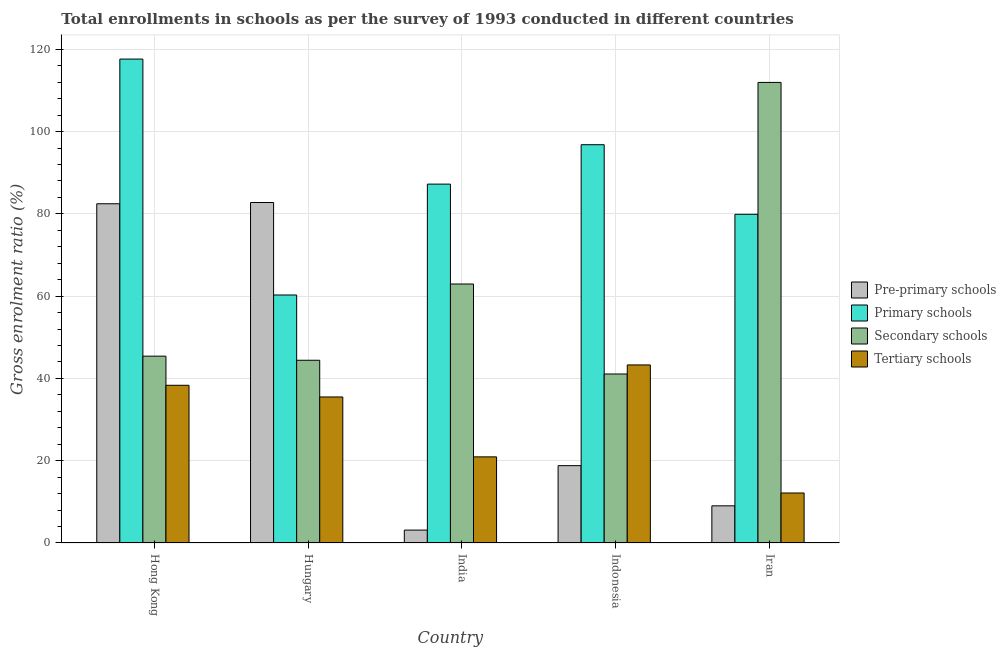How many different coloured bars are there?
Offer a terse response. 4. How many groups of bars are there?
Your answer should be compact. 5. Are the number of bars per tick equal to the number of legend labels?
Your answer should be compact. Yes. What is the label of the 1st group of bars from the left?
Provide a short and direct response. Hong Kong. What is the gross enrolment ratio in primary schools in Iran?
Make the answer very short. 79.9. Across all countries, what is the maximum gross enrolment ratio in pre-primary schools?
Offer a very short reply. 82.77. Across all countries, what is the minimum gross enrolment ratio in primary schools?
Provide a succinct answer. 60.28. In which country was the gross enrolment ratio in secondary schools maximum?
Your answer should be very brief. Iran. What is the total gross enrolment ratio in pre-primary schools in the graph?
Your answer should be compact. 196.2. What is the difference between the gross enrolment ratio in tertiary schools in India and that in Iran?
Give a very brief answer. 8.78. What is the difference between the gross enrolment ratio in tertiary schools in Indonesia and the gross enrolment ratio in primary schools in India?
Give a very brief answer. -43.95. What is the average gross enrolment ratio in pre-primary schools per country?
Offer a terse response. 39.24. What is the difference between the gross enrolment ratio in primary schools and gross enrolment ratio in tertiary schools in Hungary?
Your answer should be compact. 24.79. In how many countries, is the gross enrolment ratio in primary schools greater than 32 %?
Make the answer very short. 5. What is the ratio of the gross enrolment ratio in primary schools in Hungary to that in Iran?
Provide a succinct answer. 0.75. Is the gross enrolment ratio in secondary schools in Hungary less than that in Indonesia?
Your answer should be compact. No. Is the difference between the gross enrolment ratio in pre-primary schools in Hong Kong and Iran greater than the difference between the gross enrolment ratio in secondary schools in Hong Kong and Iran?
Your answer should be very brief. Yes. What is the difference between the highest and the second highest gross enrolment ratio in tertiary schools?
Your response must be concise. 4.95. What is the difference between the highest and the lowest gross enrolment ratio in primary schools?
Give a very brief answer. 57.35. In how many countries, is the gross enrolment ratio in secondary schools greater than the average gross enrolment ratio in secondary schools taken over all countries?
Offer a terse response. 2. Is it the case that in every country, the sum of the gross enrolment ratio in secondary schools and gross enrolment ratio in pre-primary schools is greater than the sum of gross enrolment ratio in tertiary schools and gross enrolment ratio in primary schools?
Ensure brevity in your answer.  No. What does the 4th bar from the left in Hungary represents?
Make the answer very short. Tertiary schools. What does the 4th bar from the right in Hong Kong represents?
Give a very brief answer. Pre-primary schools. Is it the case that in every country, the sum of the gross enrolment ratio in pre-primary schools and gross enrolment ratio in primary schools is greater than the gross enrolment ratio in secondary schools?
Offer a terse response. No. How many bars are there?
Your answer should be very brief. 20. Are all the bars in the graph horizontal?
Provide a succinct answer. No. How many countries are there in the graph?
Provide a short and direct response. 5. Are the values on the major ticks of Y-axis written in scientific E-notation?
Make the answer very short. No. Does the graph contain any zero values?
Offer a terse response. No. What is the title of the graph?
Offer a terse response. Total enrollments in schools as per the survey of 1993 conducted in different countries. Does "Regional development banks" appear as one of the legend labels in the graph?
Provide a short and direct response. No. What is the label or title of the X-axis?
Your response must be concise. Country. What is the label or title of the Y-axis?
Provide a short and direct response. Gross enrolment ratio (%). What is the Gross enrolment ratio (%) in Pre-primary schools in Hong Kong?
Offer a terse response. 82.46. What is the Gross enrolment ratio (%) of Primary schools in Hong Kong?
Your response must be concise. 117.63. What is the Gross enrolment ratio (%) of Secondary schools in Hong Kong?
Your response must be concise. 45.42. What is the Gross enrolment ratio (%) in Tertiary schools in Hong Kong?
Your response must be concise. 38.33. What is the Gross enrolment ratio (%) of Pre-primary schools in Hungary?
Keep it short and to the point. 82.77. What is the Gross enrolment ratio (%) of Primary schools in Hungary?
Offer a terse response. 60.28. What is the Gross enrolment ratio (%) in Secondary schools in Hungary?
Provide a succinct answer. 44.42. What is the Gross enrolment ratio (%) of Tertiary schools in Hungary?
Your answer should be compact. 35.5. What is the Gross enrolment ratio (%) of Pre-primary schools in India?
Your response must be concise. 3.14. What is the Gross enrolment ratio (%) of Primary schools in India?
Keep it short and to the point. 87.24. What is the Gross enrolment ratio (%) of Secondary schools in India?
Your response must be concise. 62.95. What is the Gross enrolment ratio (%) in Tertiary schools in India?
Give a very brief answer. 20.93. What is the Gross enrolment ratio (%) in Pre-primary schools in Indonesia?
Your answer should be very brief. 18.8. What is the Gross enrolment ratio (%) in Primary schools in Indonesia?
Keep it short and to the point. 96.82. What is the Gross enrolment ratio (%) in Secondary schools in Indonesia?
Make the answer very short. 41.08. What is the Gross enrolment ratio (%) of Tertiary schools in Indonesia?
Give a very brief answer. 43.28. What is the Gross enrolment ratio (%) in Pre-primary schools in Iran?
Give a very brief answer. 9.03. What is the Gross enrolment ratio (%) in Primary schools in Iran?
Offer a very short reply. 79.9. What is the Gross enrolment ratio (%) in Secondary schools in Iran?
Your answer should be compact. 111.96. What is the Gross enrolment ratio (%) in Tertiary schools in Iran?
Keep it short and to the point. 12.15. Across all countries, what is the maximum Gross enrolment ratio (%) in Pre-primary schools?
Offer a very short reply. 82.77. Across all countries, what is the maximum Gross enrolment ratio (%) in Primary schools?
Your answer should be compact. 117.63. Across all countries, what is the maximum Gross enrolment ratio (%) of Secondary schools?
Provide a short and direct response. 111.96. Across all countries, what is the maximum Gross enrolment ratio (%) in Tertiary schools?
Offer a very short reply. 43.28. Across all countries, what is the minimum Gross enrolment ratio (%) of Pre-primary schools?
Your answer should be very brief. 3.14. Across all countries, what is the minimum Gross enrolment ratio (%) of Primary schools?
Make the answer very short. 60.28. Across all countries, what is the minimum Gross enrolment ratio (%) in Secondary schools?
Offer a terse response. 41.08. Across all countries, what is the minimum Gross enrolment ratio (%) of Tertiary schools?
Keep it short and to the point. 12.15. What is the total Gross enrolment ratio (%) of Pre-primary schools in the graph?
Your response must be concise. 196.2. What is the total Gross enrolment ratio (%) in Primary schools in the graph?
Provide a succinct answer. 441.87. What is the total Gross enrolment ratio (%) of Secondary schools in the graph?
Offer a very short reply. 305.83. What is the total Gross enrolment ratio (%) of Tertiary schools in the graph?
Provide a short and direct response. 150.2. What is the difference between the Gross enrolment ratio (%) of Pre-primary schools in Hong Kong and that in Hungary?
Provide a short and direct response. -0.31. What is the difference between the Gross enrolment ratio (%) in Primary schools in Hong Kong and that in Hungary?
Your answer should be compact. 57.35. What is the difference between the Gross enrolment ratio (%) of Secondary schools in Hong Kong and that in Hungary?
Offer a very short reply. 1. What is the difference between the Gross enrolment ratio (%) of Tertiary schools in Hong Kong and that in Hungary?
Make the answer very short. 2.84. What is the difference between the Gross enrolment ratio (%) of Pre-primary schools in Hong Kong and that in India?
Offer a very short reply. 79.33. What is the difference between the Gross enrolment ratio (%) of Primary schools in Hong Kong and that in India?
Offer a very short reply. 30.4. What is the difference between the Gross enrolment ratio (%) in Secondary schools in Hong Kong and that in India?
Keep it short and to the point. -17.54. What is the difference between the Gross enrolment ratio (%) in Tertiary schools in Hong Kong and that in India?
Your answer should be compact. 17.4. What is the difference between the Gross enrolment ratio (%) in Pre-primary schools in Hong Kong and that in Indonesia?
Provide a short and direct response. 63.66. What is the difference between the Gross enrolment ratio (%) of Primary schools in Hong Kong and that in Indonesia?
Provide a short and direct response. 20.82. What is the difference between the Gross enrolment ratio (%) of Secondary schools in Hong Kong and that in Indonesia?
Your response must be concise. 4.34. What is the difference between the Gross enrolment ratio (%) in Tertiary schools in Hong Kong and that in Indonesia?
Your response must be concise. -4.95. What is the difference between the Gross enrolment ratio (%) in Pre-primary schools in Hong Kong and that in Iran?
Provide a short and direct response. 73.43. What is the difference between the Gross enrolment ratio (%) of Primary schools in Hong Kong and that in Iran?
Your response must be concise. 37.73. What is the difference between the Gross enrolment ratio (%) in Secondary schools in Hong Kong and that in Iran?
Provide a short and direct response. -66.54. What is the difference between the Gross enrolment ratio (%) of Tertiary schools in Hong Kong and that in Iran?
Keep it short and to the point. 26.18. What is the difference between the Gross enrolment ratio (%) of Pre-primary schools in Hungary and that in India?
Your answer should be compact. 79.63. What is the difference between the Gross enrolment ratio (%) of Primary schools in Hungary and that in India?
Keep it short and to the point. -26.95. What is the difference between the Gross enrolment ratio (%) of Secondary schools in Hungary and that in India?
Ensure brevity in your answer.  -18.54. What is the difference between the Gross enrolment ratio (%) of Tertiary schools in Hungary and that in India?
Your response must be concise. 14.56. What is the difference between the Gross enrolment ratio (%) in Pre-primary schools in Hungary and that in Indonesia?
Ensure brevity in your answer.  63.97. What is the difference between the Gross enrolment ratio (%) of Primary schools in Hungary and that in Indonesia?
Your answer should be very brief. -36.53. What is the difference between the Gross enrolment ratio (%) of Secondary schools in Hungary and that in Indonesia?
Keep it short and to the point. 3.34. What is the difference between the Gross enrolment ratio (%) of Tertiary schools in Hungary and that in Indonesia?
Make the answer very short. -7.79. What is the difference between the Gross enrolment ratio (%) in Pre-primary schools in Hungary and that in Iran?
Provide a succinct answer. 73.74. What is the difference between the Gross enrolment ratio (%) of Primary schools in Hungary and that in Iran?
Ensure brevity in your answer.  -19.62. What is the difference between the Gross enrolment ratio (%) in Secondary schools in Hungary and that in Iran?
Make the answer very short. -67.54. What is the difference between the Gross enrolment ratio (%) of Tertiary schools in Hungary and that in Iran?
Provide a succinct answer. 23.34. What is the difference between the Gross enrolment ratio (%) of Pre-primary schools in India and that in Indonesia?
Provide a short and direct response. -15.66. What is the difference between the Gross enrolment ratio (%) of Primary schools in India and that in Indonesia?
Make the answer very short. -9.58. What is the difference between the Gross enrolment ratio (%) of Secondary schools in India and that in Indonesia?
Your response must be concise. 21.87. What is the difference between the Gross enrolment ratio (%) in Tertiary schools in India and that in Indonesia?
Provide a short and direct response. -22.35. What is the difference between the Gross enrolment ratio (%) of Pre-primary schools in India and that in Iran?
Your answer should be compact. -5.9. What is the difference between the Gross enrolment ratio (%) in Primary schools in India and that in Iran?
Provide a short and direct response. 7.33. What is the difference between the Gross enrolment ratio (%) in Secondary schools in India and that in Iran?
Keep it short and to the point. -49. What is the difference between the Gross enrolment ratio (%) in Tertiary schools in India and that in Iran?
Provide a short and direct response. 8.78. What is the difference between the Gross enrolment ratio (%) in Pre-primary schools in Indonesia and that in Iran?
Provide a succinct answer. 9.77. What is the difference between the Gross enrolment ratio (%) in Primary schools in Indonesia and that in Iran?
Provide a succinct answer. 16.92. What is the difference between the Gross enrolment ratio (%) in Secondary schools in Indonesia and that in Iran?
Keep it short and to the point. -70.88. What is the difference between the Gross enrolment ratio (%) in Tertiary schools in Indonesia and that in Iran?
Your answer should be compact. 31.13. What is the difference between the Gross enrolment ratio (%) of Pre-primary schools in Hong Kong and the Gross enrolment ratio (%) of Primary schools in Hungary?
Offer a very short reply. 22.18. What is the difference between the Gross enrolment ratio (%) of Pre-primary schools in Hong Kong and the Gross enrolment ratio (%) of Secondary schools in Hungary?
Your answer should be very brief. 38.04. What is the difference between the Gross enrolment ratio (%) of Pre-primary schools in Hong Kong and the Gross enrolment ratio (%) of Tertiary schools in Hungary?
Give a very brief answer. 46.97. What is the difference between the Gross enrolment ratio (%) of Primary schools in Hong Kong and the Gross enrolment ratio (%) of Secondary schools in Hungary?
Ensure brevity in your answer.  73.21. What is the difference between the Gross enrolment ratio (%) in Primary schools in Hong Kong and the Gross enrolment ratio (%) in Tertiary schools in Hungary?
Offer a terse response. 82.14. What is the difference between the Gross enrolment ratio (%) of Secondary schools in Hong Kong and the Gross enrolment ratio (%) of Tertiary schools in Hungary?
Give a very brief answer. 9.92. What is the difference between the Gross enrolment ratio (%) in Pre-primary schools in Hong Kong and the Gross enrolment ratio (%) in Primary schools in India?
Give a very brief answer. -4.77. What is the difference between the Gross enrolment ratio (%) in Pre-primary schools in Hong Kong and the Gross enrolment ratio (%) in Secondary schools in India?
Offer a terse response. 19.51. What is the difference between the Gross enrolment ratio (%) in Pre-primary schools in Hong Kong and the Gross enrolment ratio (%) in Tertiary schools in India?
Provide a short and direct response. 61.53. What is the difference between the Gross enrolment ratio (%) of Primary schools in Hong Kong and the Gross enrolment ratio (%) of Secondary schools in India?
Your answer should be compact. 54.68. What is the difference between the Gross enrolment ratio (%) in Primary schools in Hong Kong and the Gross enrolment ratio (%) in Tertiary schools in India?
Provide a short and direct response. 96.7. What is the difference between the Gross enrolment ratio (%) of Secondary schools in Hong Kong and the Gross enrolment ratio (%) of Tertiary schools in India?
Offer a terse response. 24.48. What is the difference between the Gross enrolment ratio (%) in Pre-primary schools in Hong Kong and the Gross enrolment ratio (%) in Primary schools in Indonesia?
Your answer should be compact. -14.36. What is the difference between the Gross enrolment ratio (%) of Pre-primary schools in Hong Kong and the Gross enrolment ratio (%) of Secondary schools in Indonesia?
Your answer should be compact. 41.38. What is the difference between the Gross enrolment ratio (%) in Pre-primary schools in Hong Kong and the Gross enrolment ratio (%) in Tertiary schools in Indonesia?
Keep it short and to the point. 39.18. What is the difference between the Gross enrolment ratio (%) in Primary schools in Hong Kong and the Gross enrolment ratio (%) in Secondary schools in Indonesia?
Offer a very short reply. 76.55. What is the difference between the Gross enrolment ratio (%) in Primary schools in Hong Kong and the Gross enrolment ratio (%) in Tertiary schools in Indonesia?
Provide a short and direct response. 74.35. What is the difference between the Gross enrolment ratio (%) in Secondary schools in Hong Kong and the Gross enrolment ratio (%) in Tertiary schools in Indonesia?
Offer a very short reply. 2.13. What is the difference between the Gross enrolment ratio (%) of Pre-primary schools in Hong Kong and the Gross enrolment ratio (%) of Primary schools in Iran?
Provide a succinct answer. 2.56. What is the difference between the Gross enrolment ratio (%) in Pre-primary schools in Hong Kong and the Gross enrolment ratio (%) in Secondary schools in Iran?
Keep it short and to the point. -29.5. What is the difference between the Gross enrolment ratio (%) of Pre-primary schools in Hong Kong and the Gross enrolment ratio (%) of Tertiary schools in Iran?
Provide a short and direct response. 70.31. What is the difference between the Gross enrolment ratio (%) in Primary schools in Hong Kong and the Gross enrolment ratio (%) in Secondary schools in Iran?
Offer a terse response. 5.68. What is the difference between the Gross enrolment ratio (%) of Primary schools in Hong Kong and the Gross enrolment ratio (%) of Tertiary schools in Iran?
Make the answer very short. 105.48. What is the difference between the Gross enrolment ratio (%) in Secondary schools in Hong Kong and the Gross enrolment ratio (%) in Tertiary schools in Iran?
Ensure brevity in your answer.  33.27. What is the difference between the Gross enrolment ratio (%) of Pre-primary schools in Hungary and the Gross enrolment ratio (%) of Primary schools in India?
Ensure brevity in your answer.  -4.47. What is the difference between the Gross enrolment ratio (%) of Pre-primary schools in Hungary and the Gross enrolment ratio (%) of Secondary schools in India?
Your answer should be very brief. 19.81. What is the difference between the Gross enrolment ratio (%) of Pre-primary schools in Hungary and the Gross enrolment ratio (%) of Tertiary schools in India?
Provide a short and direct response. 61.83. What is the difference between the Gross enrolment ratio (%) of Primary schools in Hungary and the Gross enrolment ratio (%) of Secondary schools in India?
Give a very brief answer. -2.67. What is the difference between the Gross enrolment ratio (%) in Primary schools in Hungary and the Gross enrolment ratio (%) in Tertiary schools in India?
Provide a short and direct response. 39.35. What is the difference between the Gross enrolment ratio (%) in Secondary schools in Hungary and the Gross enrolment ratio (%) in Tertiary schools in India?
Your answer should be very brief. 23.48. What is the difference between the Gross enrolment ratio (%) of Pre-primary schools in Hungary and the Gross enrolment ratio (%) of Primary schools in Indonesia?
Offer a terse response. -14.05. What is the difference between the Gross enrolment ratio (%) of Pre-primary schools in Hungary and the Gross enrolment ratio (%) of Secondary schools in Indonesia?
Your answer should be compact. 41.69. What is the difference between the Gross enrolment ratio (%) in Pre-primary schools in Hungary and the Gross enrolment ratio (%) in Tertiary schools in Indonesia?
Make the answer very short. 39.48. What is the difference between the Gross enrolment ratio (%) in Primary schools in Hungary and the Gross enrolment ratio (%) in Secondary schools in Indonesia?
Your response must be concise. 19.2. What is the difference between the Gross enrolment ratio (%) in Primary schools in Hungary and the Gross enrolment ratio (%) in Tertiary schools in Indonesia?
Give a very brief answer. 17. What is the difference between the Gross enrolment ratio (%) in Secondary schools in Hungary and the Gross enrolment ratio (%) in Tertiary schools in Indonesia?
Ensure brevity in your answer.  1.13. What is the difference between the Gross enrolment ratio (%) of Pre-primary schools in Hungary and the Gross enrolment ratio (%) of Primary schools in Iran?
Your answer should be compact. 2.87. What is the difference between the Gross enrolment ratio (%) in Pre-primary schools in Hungary and the Gross enrolment ratio (%) in Secondary schools in Iran?
Your answer should be very brief. -29.19. What is the difference between the Gross enrolment ratio (%) in Pre-primary schools in Hungary and the Gross enrolment ratio (%) in Tertiary schools in Iran?
Offer a very short reply. 70.61. What is the difference between the Gross enrolment ratio (%) in Primary schools in Hungary and the Gross enrolment ratio (%) in Secondary schools in Iran?
Your answer should be very brief. -51.67. What is the difference between the Gross enrolment ratio (%) in Primary schools in Hungary and the Gross enrolment ratio (%) in Tertiary schools in Iran?
Offer a very short reply. 48.13. What is the difference between the Gross enrolment ratio (%) in Secondary schools in Hungary and the Gross enrolment ratio (%) in Tertiary schools in Iran?
Your answer should be very brief. 32.27. What is the difference between the Gross enrolment ratio (%) in Pre-primary schools in India and the Gross enrolment ratio (%) in Primary schools in Indonesia?
Offer a very short reply. -93.68. What is the difference between the Gross enrolment ratio (%) in Pre-primary schools in India and the Gross enrolment ratio (%) in Secondary schools in Indonesia?
Your response must be concise. -37.95. What is the difference between the Gross enrolment ratio (%) in Pre-primary schools in India and the Gross enrolment ratio (%) in Tertiary schools in Indonesia?
Your answer should be compact. -40.15. What is the difference between the Gross enrolment ratio (%) in Primary schools in India and the Gross enrolment ratio (%) in Secondary schools in Indonesia?
Offer a terse response. 46.15. What is the difference between the Gross enrolment ratio (%) of Primary schools in India and the Gross enrolment ratio (%) of Tertiary schools in Indonesia?
Offer a very short reply. 43.95. What is the difference between the Gross enrolment ratio (%) of Secondary schools in India and the Gross enrolment ratio (%) of Tertiary schools in Indonesia?
Keep it short and to the point. 19.67. What is the difference between the Gross enrolment ratio (%) of Pre-primary schools in India and the Gross enrolment ratio (%) of Primary schools in Iran?
Offer a very short reply. -76.77. What is the difference between the Gross enrolment ratio (%) of Pre-primary schools in India and the Gross enrolment ratio (%) of Secondary schools in Iran?
Offer a very short reply. -108.82. What is the difference between the Gross enrolment ratio (%) of Pre-primary schools in India and the Gross enrolment ratio (%) of Tertiary schools in Iran?
Give a very brief answer. -9.02. What is the difference between the Gross enrolment ratio (%) of Primary schools in India and the Gross enrolment ratio (%) of Secondary schools in Iran?
Your answer should be compact. -24.72. What is the difference between the Gross enrolment ratio (%) in Primary schools in India and the Gross enrolment ratio (%) in Tertiary schools in Iran?
Provide a succinct answer. 75.08. What is the difference between the Gross enrolment ratio (%) in Secondary schools in India and the Gross enrolment ratio (%) in Tertiary schools in Iran?
Ensure brevity in your answer.  50.8. What is the difference between the Gross enrolment ratio (%) in Pre-primary schools in Indonesia and the Gross enrolment ratio (%) in Primary schools in Iran?
Ensure brevity in your answer.  -61.1. What is the difference between the Gross enrolment ratio (%) of Pre-primary schools in Indonesia and the Gross enrolment ratio (%) of Secondary schools in Iran?
Ensure brevity in your answer.  -93.16. What is the difference between the Gross enrolment ratio (%) in Pre-primary schools in Indonesia and the Gross enrolment ratio (%) in Tertiary schools in Iran?
Provide a short and direct response. 6.65. What is the difference between the Gross enrolment ratio (%) of Primary schools in Indonesia and the Gross enrolment ratio (%) of Secondary schools in Iran?
Your answer should be compact. -15.14. What is the difference between the Gross enrolment ratio (%) in Primary schools in Indonesia and the Gross enrolment ratio (%) in Tertiary schools in Iran?
Give a very brief answer. 84.66. What is the difference between the Gross enrolment ratio (%) of Secondary schools in Indonesia and the Gross enrolment ratio (%) of Tertiary schools in Iran?
Keep it short and to the point. 28.93. What is the average Gross enrolment ratio (%) in Pre-primary schools per country?
Offer a terse response. 39.24. What is the average Gross enrolment ratio (%) in Primary schools per country?
Your answer should be compact. 88.37. What is the average Gross enrolment ratio (%) in Secondary schools per country?
Your response must be concise. 61.17. What is the average Gross enrolment ratio (%) in Tertiary schools per country?
Your answer should be very brief. 30.04. What is the difference between the Gross enrolment ratio (%) of Pre-primary schools and Gross enrolment ratio (%) of Primary schools in Hong Kong?
Provide a short and direct response. -35.17. What is the difference between the Gross enrolment ratio (%) of Pre-primary schools and Gross enrolment ratio (%) of Secondary schools in Hong Kong?
Offer a very short reply. 37.04. What is the difference between the Gross enrolment ratio (%) of Pre-primary schools and Gross enrolment ratio (%) of Tertiary schools in Hong Kong?
Offer a terse response. 44.13. What is the difference between the Gross enrolment ratio (%) of Primary schools and Gross enrolment ratio (%) of Secondary schools in Hong Kong?
Offer a terse response. 72.22. What is the difference between the Gross enrolment ratio (%) in Primary schools and Gross enrolment ratio (%) in Tertiary schools in Hong Kong?
Give a very brief answer. 79.3. What is the difference between the Gross enrolment ratio (%) in Secondary schools and Gross enrolment ratio (%) in Tertiary schools in Hong Kong?
Your answer should be very brief. 7.08. What is the difference between the Gross enrolment ratio (%) in Pre-primary schools and Gross enrolment ratio (%) in Primary schools in Hungary?
Give a very brief answer. 22.48. What is the difference between the Gross enrolment ratio (%) of Pre-primary schools and Gross enrolment ratio (%) of Secondary schools in Hungary?
Offer a terse response. 38.35. What is the difference between the Gross enrolment ratio (%) of Pre-primary schools and Gross enrolment ratio (%) of Tertiary schools in Hungary?
Provide a succinct answer. 47.27. What is the difference between the Gross enrolment ratio (%) in Primary schools and Gross enrolment ratio (%) in Secondary schools in Hungary?
Your answer should be compact. 15.87. What is the difference between the Gross enrolment ratio (%) of Primary schools and Gross enrolment ratio (%) of Tertiary schools in Hungary?
Make the answer very short. 24.79. What is the difference between the Gross enrolment ratio (%) of Secondary schools and Gross enrolment ratio (%) of Tertiary schools in Hungary?
Provide a succinct answer. 8.92. What is the difference between the Gross enrolment ratio (%) of Pre-primary schools and Gross enrolment ratio (%) of Primary schools in India?
Keep it short and to the point. -84.1. What is the difference between the Gross enrolment ratio (%) in Pre-primary schools and Gross enrolment ratio (%) in Secondary schools in India?
Your response must be concise. -59.82. What is the difference between the Gross enrolment ratio (%) of Pre-primary schools and Gross enrolment ratio (%) of Tertiary schools in India?
Give a very brief answer. -17.8. What is the difference between the Gross enrolment ratio (%) of Primary schools and Gross enrolment ratio (%) of Secondary schools in India?
Provide a short and direct response. 24.28. What is the difference between the Gross enrolment ratio (%) in Primary schools and Gross enrolment ratio (%) in Tertiary schools in India?
Give a very brief answer. 66.3. What is the difference between the Gross enrolment ratio (%) in Secondary schools and Gross enrolment ratio (%) in Tertiary schools in India?
Your response must be concise. 42.02. What is the difference between the Gross enrolment ratio (%) in Pre-primary schools and Gross enrolment ratio (%) in Primary schools in Indonesia?
Your response must be concise. -78.02. What is the difference between the Gross enrolment ratio (%) of Pre-primary schools and Gross enrolment ratio (%) of Secondary schools in Indonesia?
Offer a very short reply. -22.28. What is the difference between the Gross enrolment ratio (%) in Pre-primary schools and Gross enrolment ratio (%) in Tertiary schools in Indonesia?
Offer a very short reply. -24.48. What is the difference between the Gross enrolment ratio (%) of Primary schools and Gross enrolment ratio (%) of Secondary schools in Indonesia?
Keep it short and to the point. 55.73. What is the difference between the Gross enrolment ratio (%) in Primary schools and Gross enrolment ratio (%) in Tertiary schools in Indonesia?
Your answer should be compact. 53.53. What is the difference between the Gross enrolment ratio (%) of Secondary schools and Gross enrolment ratio (%) of Tertiary schools in Indonesia?
Ensure brevity in your answer.  -2.2. What is the difference between the Gross enrolment ratio (%) of Pre-primary schools and Gross enrolment ratio (%) of Primary schools in Iran?
Make the answer very short. -70.87. What is the difference between the Gross enrolment ratio (%) in Pre-primary schools and Gross enrolment ratio (%) in Secondary schools in Iran?
Your response must be concise. -102.93. What is the difference between the Gross enrolment ratio (%) in Pre-primary schools and Gross enrolment ratio (%) in Tertiary schools in Iran?
Ensure brevity in your answer.  -3.12. What is the difference between the Gross enrolment ratio (%) of Primary schools and Gross enrolment ratio (%) of Secondary schools in Iran?
Give a very brief answer. -32.06. What is the difference between the Gross enrolment ratio (%) of Primary schools and Gross enrolment ratio (%) of Tertiary schools in Iran?
Provide a succinct answer. 67.75. What is the difference between the Gross enrolment ratio (%) in Secondary schools and Gross enrolment ratio (%) in Tertiary schools in Iran?
Offer a terse response. 99.81. What is the ratio of the Gross enrolment ratio (%) in Primary schools in Hong Kong to that in Hungary?
Your answer should be very brief. 1.95. What is the ratio of the Gross enrolment ratio (%) of Secondary schools in Hong Kong to that in Hungary?
Your response must be concise. 1.02. What is the ratio of the Gross enrolment ratio (%) of Tertiary schools in Hong Kong to that in Hungary?
Your answer should be very brief. 1.08. What is the ratio of the Gross enrolment ratio (%) in Pre-primary schools in Hong Kong to that in India?
Your response must be concise. 26.3. What is the ratio of the Gross enrolment ratio (%) of Primary schools in Hong Kong to that in India?
Give a very brief answer. 1.35. What is the ratio of the Gross enrolment ratio (%) in Secondary schools in Hong Kong to that in India?
Ensure brevity in your answer.  0.72. What is the ratio of the Gross enrolment ratio (%) in Tertiary schools in Hong Kong to that in India?
Your response must be concise. 1.83. What is the ratio of the Gross enrolment ratio (%) of Pre-primary schools in Hong Kong to that in Indonesia?
Make the answer very short. 4.39. What is the ratio of the Gross enrolment ratio (%) of Primary schools in Hong Kong to that in Indonesia?
Offer a very short reply. 1.22. What is the ratio of the Gross enrolment ratio (%) of Secondary schools in Hong Kong to that in Indonesia?
Offer a terse response. 1.11. What is the ratio of the Gross enrolment ratio (%) in Tertiary schools in Hong Kong to that in Indonesia?
Provide a short and direct response. 0.89. What is the ratio of the Gross enrolment ratio (%) of Pre-primary schools in Hong Kong to that in Iran?
Provide a succinct answer. 9.13. What is the ratio of the Gross enrolment ratio (%) in Primary schools in Hong Kong to that in Iran?
Offer a terse response. 1.47. What is the ratio of the Gross enrolment ratio (%) of Secondary schools in Hong Kong to that in Iran?
Your answer should be compact. 0.41. What is the ratio of the Gross enrolment ratio (%) of Tertiary schools in Hong Kong to that in Iran?
Provide a succinct answer. 3.15. What is the ratio of the Gross enrolment ratio (%) of Pre-primary schools in Hungary to that in India?
Offer a very short reply. 26.4. What is the ratio of the Gross enrolment ratio (%) of Primary schools in Hungary to that in India?
Ensure brevity in your answer.  0.69. What is the ratio of the Gross enrolment ratio (%) in Secondary schools in Hungary to that in India?
Keep it short and to the point. 0.71. What is the ratio of the Gross enrolment ratio (%) of Tertiary schools in Hungary to that in India?
Offer a terse response. 1.7. What is the ratio of the Gross enrolment ratio (%) in Pre-primary schools in Hungary to that in Indonesia?
Offer a terse response. 4.4. What is the ratio of the Gross enrolment ratio (%) in Primary schools in Hungary to that in Indonesia?
Give a very brief answer. 0.62. What is the ratio of the Gross enrolment ratio (%) in Secondary schools in Hungary to that in Indonesia?
Your response must be concise. 1.08. What is the ratio of the Gross enrolment ratio (%) of Tertiary schools in Hungary to that in Indonesia?
Keep it short and to the point. 0.82. What is the ratio of the Gross enrolment ratio (%) of Pre-primary schools in Hungary to that in Iran?
Provide a short and direct response. 9.16. What is the ratio of the Gross enrolment ratio (%) in Primary schools in Hungary to that in Iran?
Give a very brief answer. 0.75. What is the ratio of the Gross enrolment ratio (%) in Secondary schools in Hungary to that in Iran?
Your response must be concise. 0.4. What is the ratio of the Gross enrolment ratio (%) of Tertiary schools in Hungary to that in Iran?
Offer a very short reply. 2.92. What is the ratio of the Gross enrolment ratio (%) in Pre-primary schools in India to that in Indonesia?
Make the answer very short. 0.17. What is the ratio of the Gross enrolment ratio (%) of Primary schools in India to that in Indonesia?
Your response must be concise. 0.9. What is the ratio of the Gross enrolment ratio (%) in Secondary schools in India to that in Indonesia?
Provide a succinct answer. 1.53. What is the ratio of the Gross enrolment ratio (%) of Tertiary schools in India to that in Indonesia?
Your answer should be very brief. 0.48. What is the ratio of the Gross enrolment ratio (%) of Pre-primary schools in India to that in Iran?
Your answer should be very brief. 0.35. What is the ratio of the Gross enrolment ratio (%) in Primary schools in India to that in Iran?
Offer a terse response. 1.09. What is the ratio of the Gross enrolment ratio (%) in Secondary schools in India to that in Iran?
Ensure brevity in your answer.  0.56. What is the ratio of the Gross enrolment ratio (%) of Tertiary schools in India to that in Iran?
Make the answer very short. 1.72. What is the ratio of the Gross enrolment ratio (%) of Pre-primary schools in Indonesia to that in Iran?
Offer a terse response. 2.08. What is the ratio of the Gross enrolment ratio (%) in Primary schools in Indonesia to that in Iran?
Your response must be concise. 1.21. What is the ratio of the Gross enrolment ratio (%) in Secondary schools in Indonesia to that in Iran?
Give a very brief answer. 0.37. What is the ratio of the Gross enrolment ratio (%) of Tertiary schools in Indonesia to that in Iran?
Ensure brevity in your answer.  3.56. What is the difference between the highest and the second highest Gross enrolment ratio (%) of Pre-primary schools?
Give a very brief answer. 0.31. What is the difference between the highest and the second highest Gross enrolment ratio (%) of Primary schools?
Your answer should be very brief. 20.82. What is the difference between the highest and the second highest Gross enrolment ratio (%) in Secondary schools?
Keep it short and to the point. 49. What is the difference between the highest and the second highest Gross enrolment ratio (%) of Tertiary schools?
Make the answer very short. 4.95. What is the difference between the highest and the lowest Gross enrolment ratio (%) of Pre-primary schools?
Give a very brief answer. 79.63. What is the difference between the highest and the lowest Gross enrolment ratio (%) in Primary schools?
Your answer should be compact. 57.35. What is the difference between the highest and the lowest Gross enrolment ratio (%) of Secondary schools?
Provide a short and direct response. 70.88. What is the difference between the highest and the lowest Gross enrolment ratio (%) of Tertiary schools?
Provide a short and direct response. 31.13. 